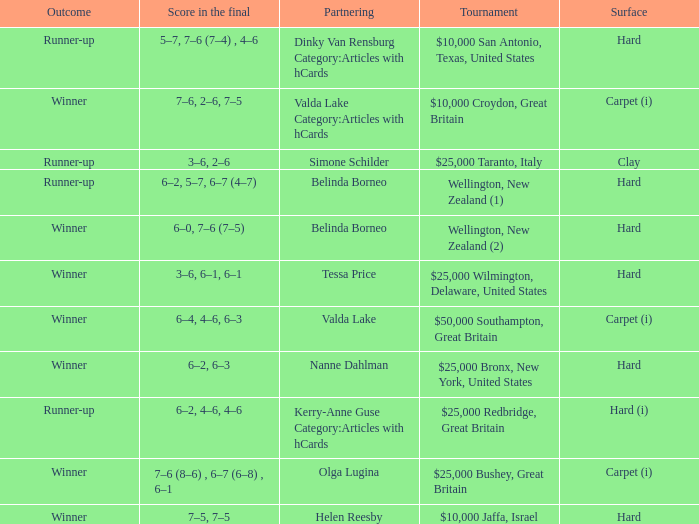What was the final score for the match with a partnering of Tessa Price? 3–6, 6–1, 6–1. 